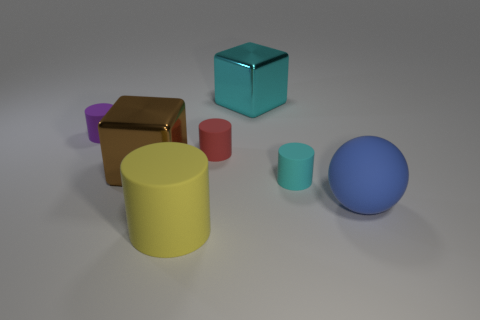Add 1 big blocks. How many objects exist? 8 Subtract all yellow rubber cylinders. How many cylinders are left? 3 Subtract 1 cylinders. How many cylinders are left? 3 Subtract all purple cylinders. How many cylinders are left? 3 Subtract 0 purple spheres. How many objects are left? 7 Subtract all blocks. How many objects are left? 5 Subtract all cyan cylinders. Subtract all green spheres. How many cylinders are left? 3 Subtract all cyan balls. How many gray cubes are left? 0 Subtract all red cylinders. Subtract all big spheres. How many objects are left? 5 Add 6 brown objects. How many brown objects are left? 7 